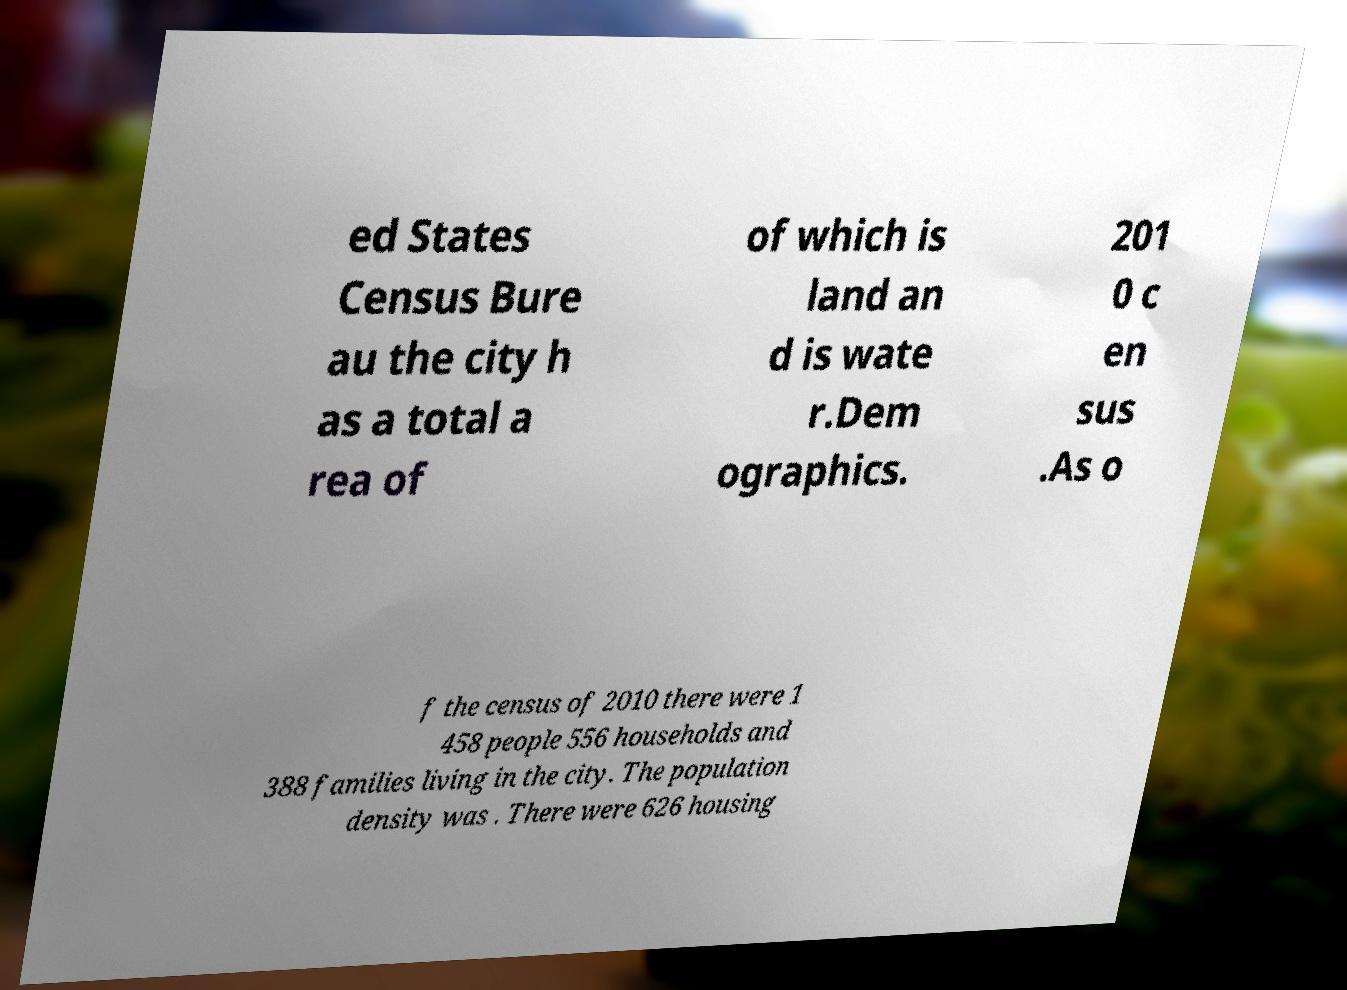Can you accurately transcribe the text from the provided image for me? ed States Census Bure au the city h as a total a rea of of which is land an d is wate r.Dem ographics. 201 0 c en sus .As o f the census of 2010 there were 1 458 people 556 households and 388 families living in the city. The population density was . There were 626 housing 